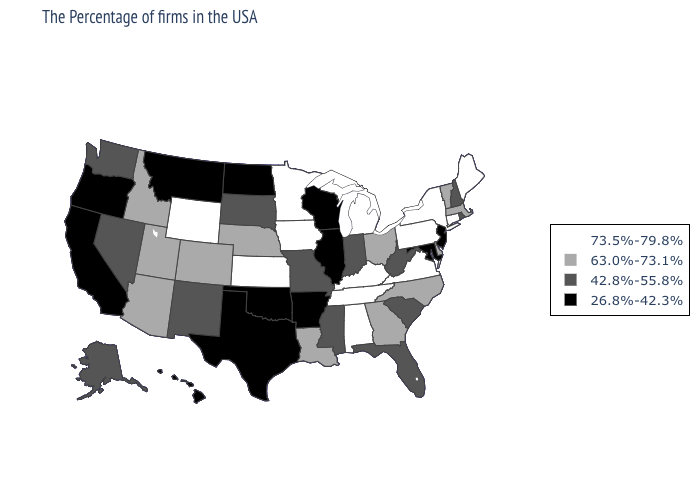What is the value of Minnesota?
Keep it brief. 73.5%-79.8%. Among the states that border Wyoming , which have the lowest value?
Concise answer only. Montana. Which states have the highest value in the USA?
Answer briefly. Maine, Connecticut, New York, Pennsylvania, Virginia, Michigan, Kentucky, Alabama, Tennessee, Minnesota, Iowa, Kansas, Wyoming. Among the states that border Pennsylvania , does West Virginia have the lowest value?
Write a very short answer. No. Name the states that have a value in the range 73.5%-79.8%?
Concise answer only. Maine, Connecticut, New York, Pennsylvania, Virginia, Michigan, Kentucky, Alabama, Tennessee, Minnesota, Iowa, Kansas, Wyoming. Does Maine have the highest value in the USA?
Answer briefly. Yes. Name the states that have a value in the range 63.0%-73.1%?
Keep it brief. Massachusetts, Vermont, Delaware, North Carolina, Ohio, Georgia, Louisiana, Nebraska, Colorado, Utah, Arizona, Idaho. Does Arkansas have the lowest value in the South?
Be succinct. Yes. Name the states that have a value in the range 73.5%-79.8%?
Answer briefly. Maine, Connecticut, New York, Pennsylvania, Virginia, Michigan, Kentucky, Alabama, Tennessee, Minnesota, Iowa, Kansas, Wyoming. Does New Hampshire have the same value as Missouri?
Quick response, please. Yes. Is the legend a continuous bar?
Quick response, please. No. What is the highest value in the South ?
Be succinct. 73.5%-79.8%. What is the lowest value in the MidWest?
Short answer required. 26.8%-42.3%. 